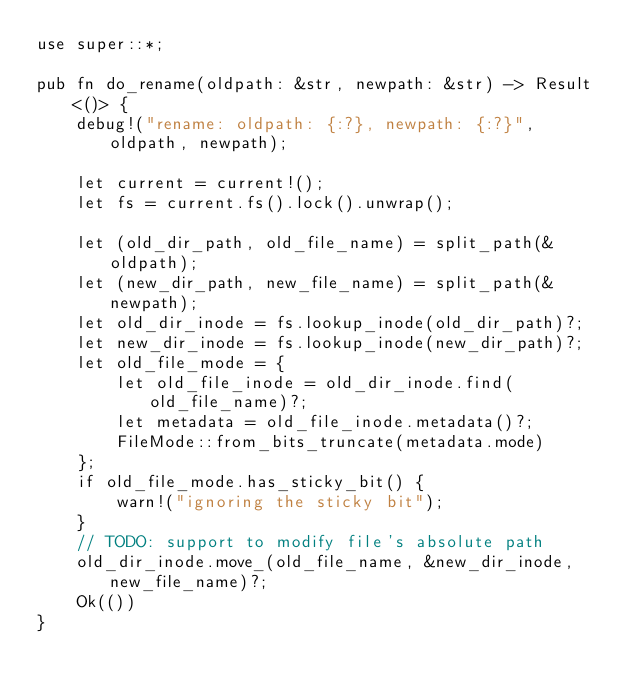Convert code to text. <code><loc_0><loc_0><loc_500><loc_500><_Rust_>use super::*;

pub fn do_rename(oldpath: &str, newpath: &str) -> Result<()> {
    debug!("rename: oldpath: {:?}, newpath: {:?}", oldpath, newpath);

    let current = current!();
    let fs = current.fs().lock().unwrap();

    let (old_dir_path, old_file_name) = split_path(&oldpath);
    let (new_dir_path, new_file_name) = split_path(&newpath);
    let old_dir_inode = fs.lookup_inode(old_dir_path)?;
    let new_dir_inode = fs.lookup_inode(new_dir_path)?;
    let old_file_mode = {
        let old_file_inode = old_dir_inode.find(old_file_name)?;
        let metadata = old_file_inode.metadata()?;
        FileMode::from_bits_truncate(metadata.mode)
    };
    if old_file_mode.has_sticky_bit() {
        warn!("ignoring the sticky bit");
    }
    // TODO: support to modify file's absolute path
    old_dir_inode.move_(old_file_name, &new_dir_inode, new_file_name)?;
    Ok(())
}
</code> 